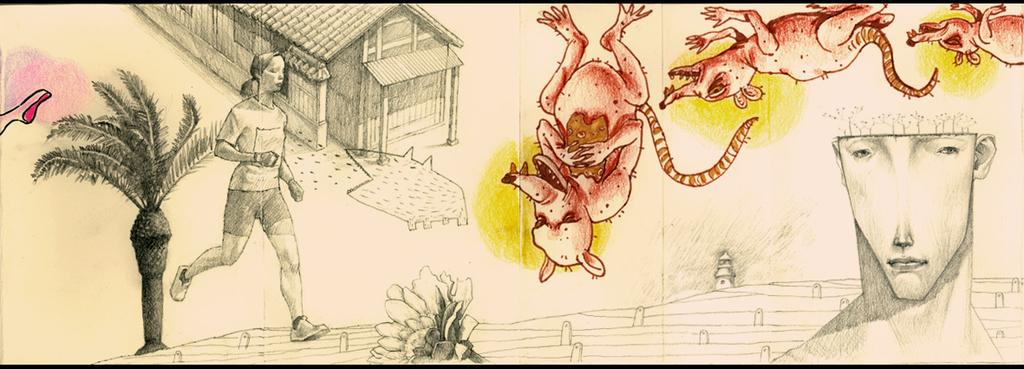What is the main subject of the sketch in the image? The main subject of the sketch in the image is a house. What features of the house are included in the sketch? The sketch includes windows and a person. What other elements are present in the sketch? A tree, a flower, and animals with different colors are present in the sketch. Can you describe the person in the sketch? The person's face is visible in the sketch. What type of grass is growing around the house in the sketch? There is no grass present in the sketch; it only includes a house, windows, a person, a tree, a flower, and animals with different colors. 